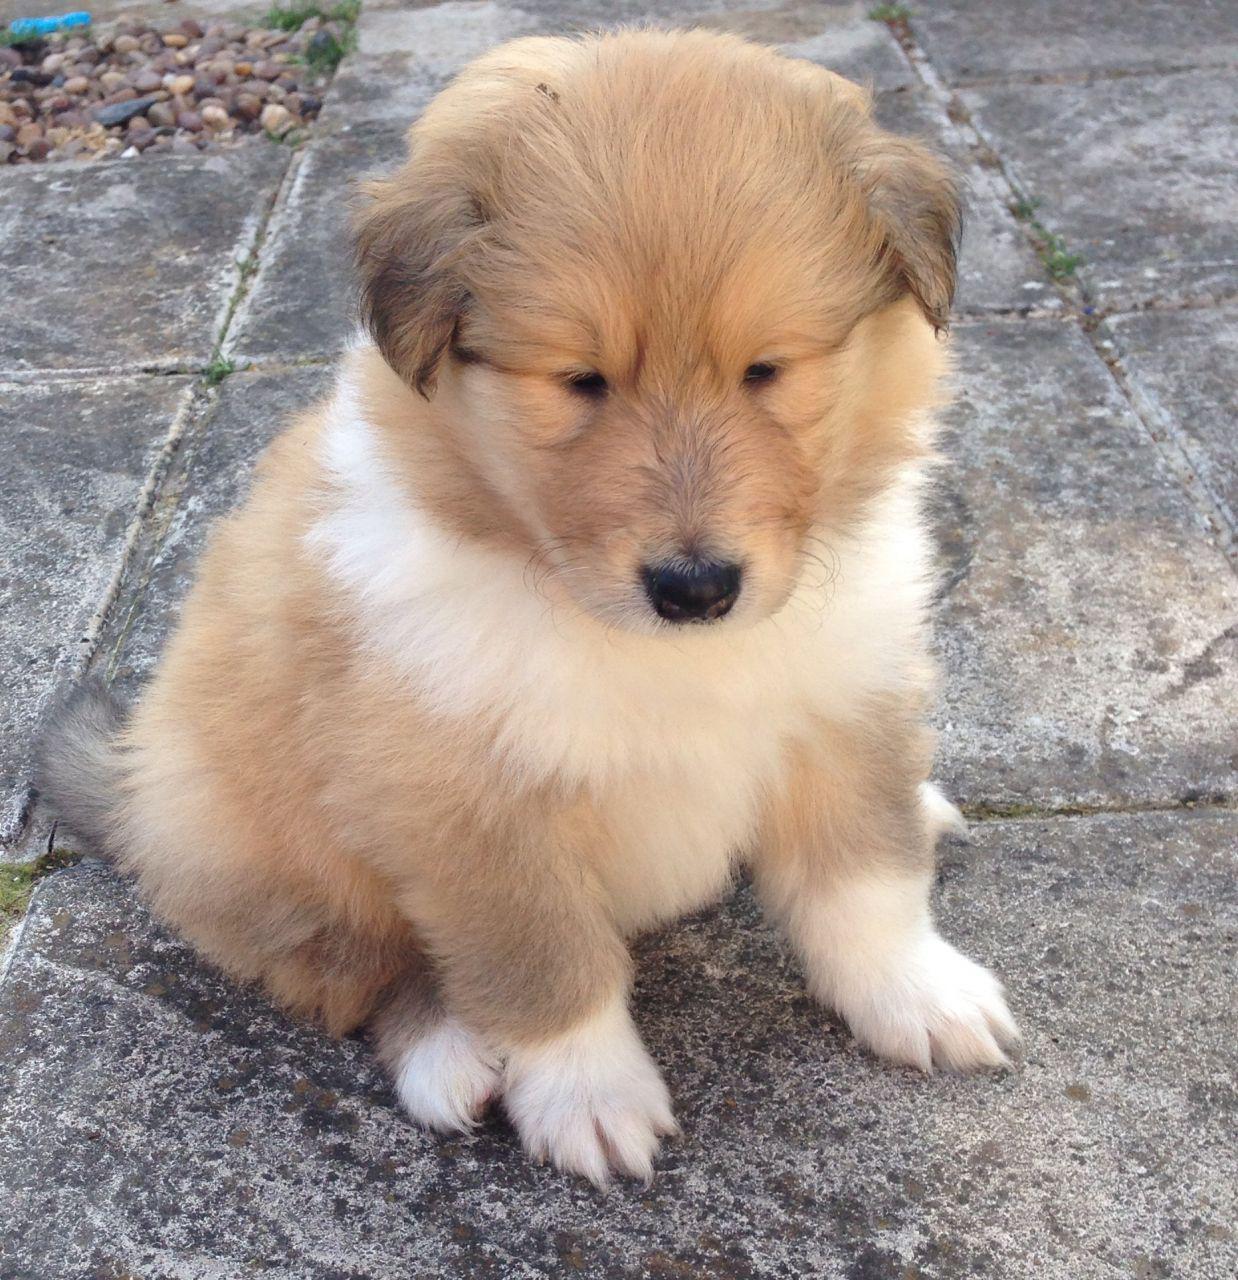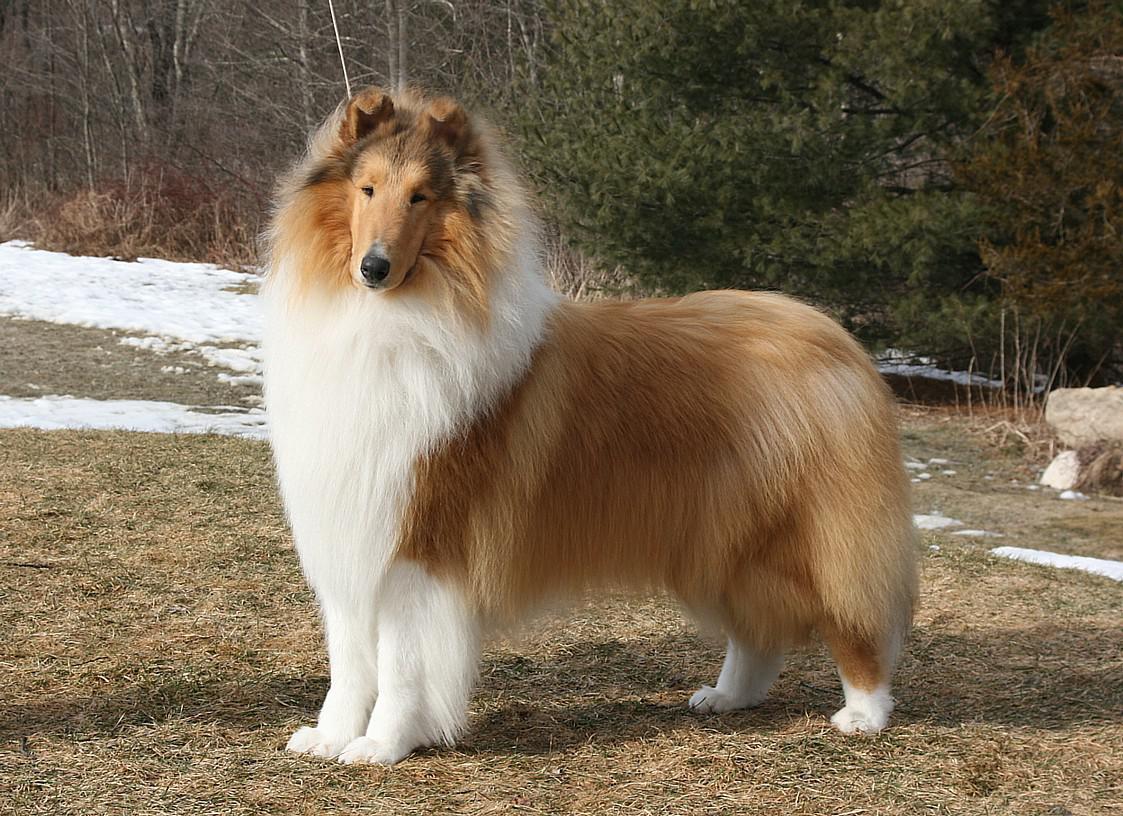The first image is the image on the left, the second image is the image on the right. For the images shown, is this caption "There is dog on top of grass in one of the images." true? Answer yes or no. Yes. The first image is the image on the left, the second image is the image on the right. Considering the images on both sides, is "there are two dogs in the image pair" valid? Answer yes or no. Yes. 